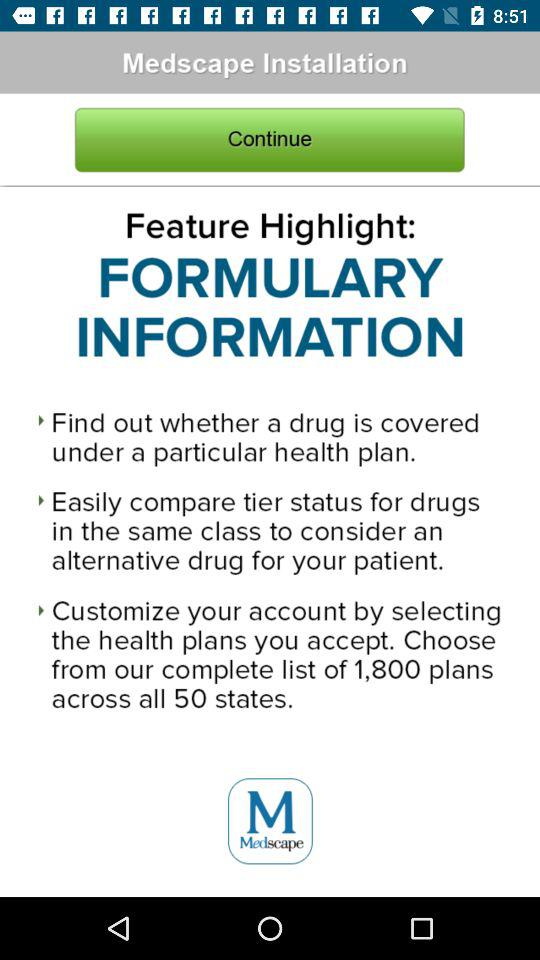How many feature highlights are on this screen?
Answer the question using a single word or phrase. 3 